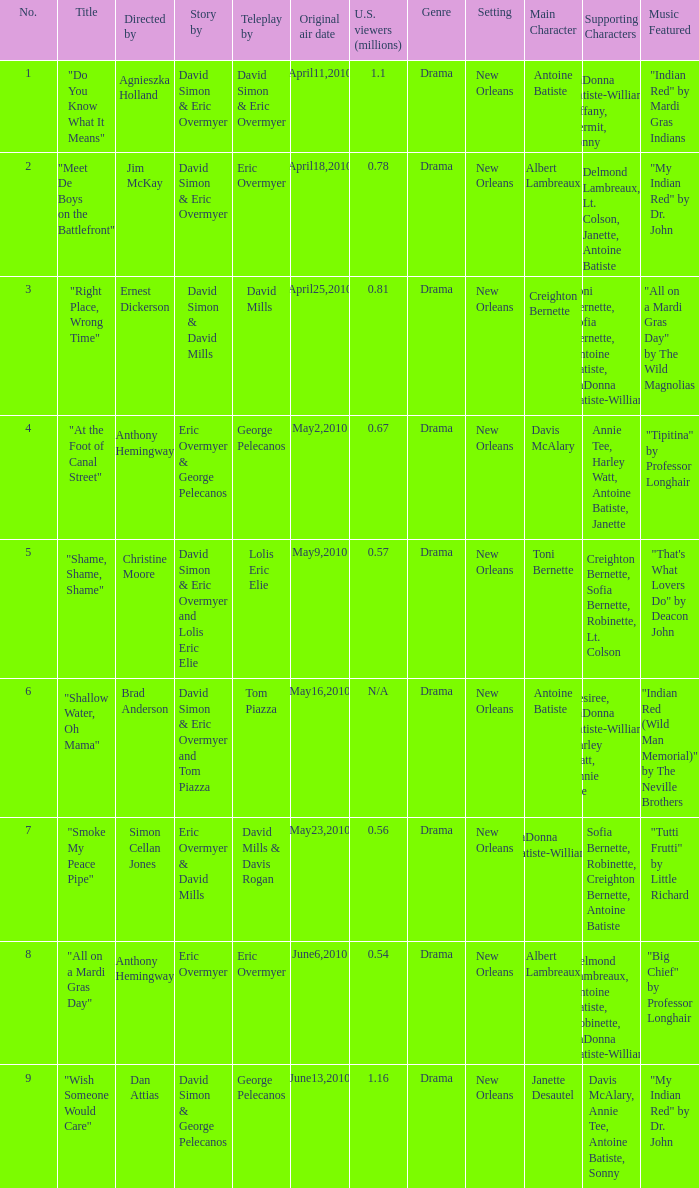Help me parse the entirety of this table. {'header': ['No.', 'Title', 'Directed by', 'Story by', 'Teleplay by', 'Original air date', 'U.S. viewers (millions)', 'Genre', 'Setting', 'Main Character', 'Supporting Characters', 'Music Featured'], 'rows': [['1', '"Do You Know What It Means"', 'Agnieszka Holland', 'David Simon & Eric Overmyer', 'David Simon & Eric Overmyer', 'April11,2010', '1.1', 'Drama', 'New Orleans', 'Antoine Batiste', 'LaDonna Batiste-Williams, Tiffany, Kermit, Sonny', '"Indian Red" by Mardi Gras Indians'], ['2', '"Meet De Boys on the Battlefront"', 'Jim McKay', 'David Simon & Eric Overmyer', 'Eric Overmyer', 'April18,2010', '0.78', 'Drama', 'New Orleans', 'Albert Lambreaux', 'Delmond Lambreaux, Lt. Colson, Janette, Antoine Batiste', '"My Indian Red" by Dr. John'], ['3', '"Right Place, Wrong Time"', 'Ernest Dickerson', 'David Simon & David Mills', 'David Mills', 'April25,2010', '0.81', 'Drama', 'New Orleans', 'Creighton Bernette', 'Toni Bernette, Sofia Bernette, Antoine Batiste, LaDonna Batiste-Williams', '"All on a Mardi Gras Day" by The Wild Magnolias'], ['4', '"At the Foot of Canal Street"', 'Anthony Hemingway', 'Eric Overmyer & George Pelecanos', 'George Pelecanos', 'May2,2010', '0.67', 'Drama', 'New Orleans', 'Davis McAlary', 'Annie Tee, Harley Watt, Antoine Batiste, Janette', '"Tipitina" by Professor Longhair'], ['5', '"Shame, Shame, Shame"', 'Christine Moore', 'David Simon & Eric Overmyer and Lolis Eric Elie', 'Lolis Eric Elie', 'May9,2010', '0.57', 'Drama', 'New Orleans', 'Toni Bernette', 'Creighton Bernette, Sofia Bernette, Robinette, Lt. Colson', '"That\'s What Lovers Do" by Deacon John'], ['6', '"Shallow Water, Oh Mama"', 'Brad Anderson', 'David Simon & Eric Overmyer and Tom Piazza', 'Tom Piazza', 'May16,2010', 'N/A', 'Drama', 'New Orleans', 'Antoine Batiste', 'Desiree, LaDonna Batiste-Williams, Harley Watt, Annie Tee', '"Indian Red (Wild Man Memorial)" by The Neville Brothers'], ['7', '"Smoke My Peace Pipe"', 'Simon Cellan Jones', 'Eric Overmyer & David Mills', 'David Mills & Davis Rogan', 'May23,2010', '0.56', 'Drama', 'New Orleans', 'LaDonna Batiste-Williams', 'Sofia Bernette, Robinette, Creighton Bernette, Antoine Batiste', '"Tutti Frutti" by Little Richard'], ['8', '"All on a Mardi Gras Day"', 'Anthony Hemingway', 'Eric Overmyer', 'Eric Overmyer', 'June6,2010', '0.54', 'Drama', 'New Orleans', 'Albert Lambreaux', 'Delmond Lambreaux, Antoine Batiste, Robinette, LaDonna Batiste-Williams', '"Big Chief" by Professor Longhair'], ['9', '"Wish Someone Would Care"', 'Dan Attias', 'David Simon & George Pelecanos', 'George Pelecanos', 'June13,2010', '1.16', 'Drama', 'New Orleans', 'Janette Desautel', 'Davis McAlary, Annie Tee, Antoine Batiste, Sonny', '"My Indian Red" by Dr. John']]} Name the us viewers directed by christine moore 0.57. 